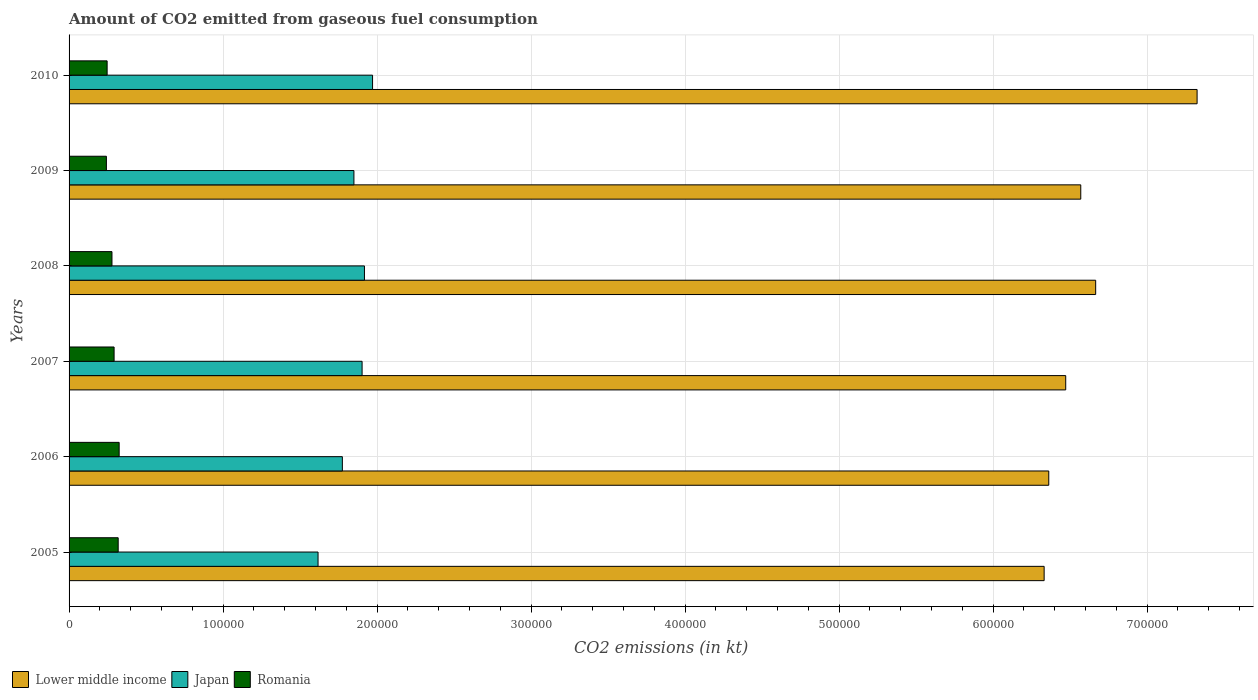How many groups of bars are there?
Ensure brevity in your answer.  6. Are the number of bars per tick equal to the number of legend labels?
Your response must be concise. Yes. In how many cases, is the number of bars for a given year not equal to the number of legend labels?
Keep it short and to the point. 0. What is the amount of CO2 emitted in Romania in 2006?
Provide a succinct answer. 3.25e+04. Across all years, what is the maximum amount of CO2 emitted in Romania?
Your response must be concise. 3.25e+04. Across all years, what is the minimum amount of CO2 emitted in Japan?
Give a very brief answer. 1.62e+05. In which year was the amount of CO2 emitted in Lower middle income minimum?
Offer a terse response. 2005. What is the total amount of CO2 emitted in Romania in the graph?
Provide a succinct answer. 1.70e+05. What is the difference between the amount of CO2 emitted in Romania in 2007 and that in 2009?
Ensure brevity in your answer.  4998.12. What is the difference between the amount of CO2 emitted in Romania in 2009 and the amount of CO2 emitted in Japan in 2007?
Your answer should be compact. -1.66e+05. What is the average amount of CO2 emitted in Japan per year?
Make the answer very short. 1.84e+05. In the year 2006, what is the difference between the amount of CO2 emitted in Japan and amount of CO2 emitted in Lower middle income?
Give a very brief answer. -4.59e+05. In how many years, is the amount of CO2 emitted in Japan greater than 200000 kt?
Keep it short and to the point. 0. What is the ratio of the amount of CO2 emitted in Japan in 2007 to that in 2009?
Make the answer very short. 1.03. Is the difference between the amount of CO2 emitted in Japan in 2009 and 2010 greater than the difference between the amount of CO2 emitted in Lower middle income in 2009 and 2010?
Make the answer very short. Yes. What is the difference between the highest and the second highest amount of CO2 emitted in Lower middle income?
Provide a short and direct response. 6.59e+04. What is the difference between the highest and the lowest amount of CO2 emitted in Lower middle income?
Keep it short and to the point. 9.93e+04. In how many years, is the amount of CO2 emitted in Japan greater than the average amount of CO2 emitted in Japan taken over all years?
Keep it short and to the point. 4. Is the sum of the amount of CO2 emitted in Lower middle income in 2006 and 2010 greater than the maximum amount of CO2 emitted in Japan across all years?
Make the answer very short. Yes. What does the 3rd bar from the top in 2006 represents?
Provide a short and direct response. Lower middle income. What does the 3rd bar from the bottom in 2009 represents?
Your answer should be compact. Romania. How many bars are there?
Offer a very short reply. 18. How many legend labels are there?
Give a very brief answer. 3. How are the legend labels stacked?
Offer a very short reply. Horizontal. What is the title of the graph?
Offer a very short reply. Amount of CO2 emitted from gaseous fuel consumption. Does "Qatar" appear as one of the legend labels in the graph?
Give a very brief answer. No. What is the label or title of the X-axis?
Ensure brevity in your answer.  CO2 emissions (in kt). What is the CO2 emissions (in kt) in Lower middle income in 2005?
Your answer should be compact. 6.33e+05. What is the CO2 emissions (in kt) of Japan in 2005?
Give a very brief answer. 1.62e+05. What is the CO2 emissions (in kt) in Romania in 2005?
Your answer should be very brief. 3.19e+04. What is the CO2 emissions (in kt) of Lower middle income in 2006?
Ensure brevity in your answer.  6.36e+05. What is the CO2 emissions (in kt) in Japan in 2006?
Offer a very short reply. 1.77e+05. What is the CO2 emissions (in kt) in Romania in 2006?
Give a very brief answer. 3.25e+04. What is the CO2 emissions (in kt) of Lower middle income in 2007?
Offer a terse response. 6.47e+05. What is the CO2 emissions (in kt) in Japan in 2007?
Offer a terse response. 1.90e+05. What is the CO2 emissions (in kt) of Romania in 2007?
Your answer should be very brief. 2.92e+04. What is the CO2 emissions (in kt) in Lower middle income in 2008?
Offer a terse response. 6.67e+05. What is the CO2 emissions (in kt) in Japan in 2008?
Ensure brevity in your answer.  1.92e+05. What is the CO2 emissions (in kt) in Romania in 2008?
Your answer should be compact. 2.79e+04. What is the CO2 emissions (in kt) of Lower middle income in 2009?
Ensure brevity in your answer.  6.57e+05. What is the CO2 emissions (in kt) of Japan in 2009?
Provide a succinct answer. 1.85e+05. What is the CO2 emissions (in kt) in Romania in 2009?
Keep it short and to the point. 2.42e+04. What is the CO2 emissions (in kt) in Lower middle income in 2010?
Your answer should be very brief. 7.32e+05. What is the CO2 emissions (in kt) in Japan in 2010?
Offer a very short reply. 1.97e+05. What is the CO2 emissions (in kt) in Romania in 2010?
Provide a succinct answer. 2.47e+04. Across all years, what is the maximum CO2 emissions (in kt) of Lower middle income?
Offer a terse response. 7.32e+05. Across all years, what is the maximum CO2 emissions (in kt) in Japan?
Offer a very short reply. 1.97e+05. Across all years, what is the maximum CO2 emissions (in kt) of Romania?
Make the answer very short. 3.25e+04. Across all years, what is the minimum CO2 emissions (in kt) of Lower middle income?
Offer a very short reply. 6.33e+05. Across all years, what is the minimum CO2 emissions (in kt) in Japan?
Your answer should be compact. 1.62e+05. Across all years, what is the minimum CO2 emissions (in kt) of Romania?
Keep it short and to the point. 2.42e+04. What is the total CO2 emissions (in kt) in Lower middle income in the graph?
Your answer should be compact. 3.97e+06. What is the total CO2 emissions (in kt) of Japan in the graph?
Keep it short and to the point. 1.10e+06. What is the total CO2 emissions (in kt) of Romania in the graph?
Your response must be concise. 1.70e+05. What is the difference between the CO2 emissions (in kt) in Lower middle income in 2005 and that in 2006?
Your answer should be compact. -3003.93. What is the difference between the CO2 emissions (in kt) of Japan in 2005 and that in 2006?
Keep it short and to the point. -1.58e+04. What is the difference between the CO2 emissions (in kt) of Romania in 2005 and that in 2006?
Make the answer very short. -630.72. What is the difference between the CO2 emissions (in kt) of Lower middle income in 2005 and that in 2007?
Provide a short and direct response. -1.40e+04. What is the difference between the CO2 emissions (in kt) of Japan in 2005 and that in 2007?
Ensure brevity in your answer.  -2.86e+04. What is the difference between the CO2 emissions (in kt) in Romania in 2005 and that in 2007?
Make the answer very short. 2658.57. What is the difference between the CO2 emissions (in kt) of Lower middle income in 2005 and that in 2008?
Your answer should be very brief. -3.35e+04. What is the difference between the CO2 emissions (in kt) of Japan in 2005 and that in 2008?
Provide a short and direct response. -3.01e+04. What is the difference between the CO2 emissions (in kt) in Romania in 2005 and that in 2008?
Provide a short and direct response. 4037.37. What is the difference between the CO2 emissions (in kt) in Lower middle income in 2005 and that in 2009?
Provide a short and direct response. -2.38e+04. What is the difference between the CO2 emissions (in kt) in Japan in 2005 and that in 2009?
Your response must be concise. -2.33e+04. What is the difference between the CO2 emissions (in kt) in Romania in 2005 and that in 2009?
Make the answer very short. 7656.7. What is the difference between the CO2 emissions (in kt) of Lower middle income in 2005 and that in 2010?
Offer a terse response. -9.93e+04. What is the difference between the CO2 emissions (in kt) in Japan in 2005 and that in 2010?
Provide a short and direct response. -3.54e+04. What is the difference between the CO2 emissions (in kt) of Romania in 2005 and that in 2010?
Make the answer very short. 7179.99. What is the difference between the CO2 emissions (in kt) in Lower middle income in 2006 and that in 2007?
Ensure brevity in your answer.  -1.10e+04. What is the difference between the CO2 emissions (in kt) in Japan in 2006 and that in 2007?
Your answer should be compact. -1.28e+04. What is the difference between the CO2 emissions (in kt) in Romania in 2006 and that in 2007?
Ensure brevity in your answer.  3289.3. What is the difference between the CO2 emissions (in kt) of Lower middle income in 2006 and that in 2008?
Offer a terse response. -3.04e+04. What is the difference between the CO2 emissions (in kt) in Japan in 2006 and that in 2008?
Your response must be concise. -1.43e+04. What is the difference between the CO2 emissions (in kt) of Romania in 2006 and that in 2008?
Offer a terse response. 4668.09. What is the difference between the CO2 emissions (in kt) of Lower middle income in 2006 and that in 2009?
Offer a very short reply. -2.08e+04. What is the difference between the CO2 emissions (in kt) of Japan in 2006 and that in 2009?
Offer a very short reply. -7510.02. What is the difference between the CO2 emissions (in kt) of Romania in 2006 and that in 2009?
Your answer should be very brief. 8287.42. What is the difference between the CO2 emissions (in kt) of Lower middle income in 2006 and that in 2010?
Your answer should be compact. -9.63e+04. What is the difference between the CO2 emissions (in kt) in Japan in 2006 and that in 2010?
Offer a very short reply. -1.96e+04. What is the difference between the CO2 emissions (in kt) of Romania in 2006 and that in 2010?
Ensure brevity in your answer.  7810.71. What is the difference between the CO2 emissions (in kt) in Lower middle income in 2007 and that in 2008?
Provide a short and direct response. -1.94e+04. What is the difference between the CO2 emissions (in kt) in Japan in 2007 and that in 2008?
Your response must be concise. -1532.81. What is the difference between the CO2 emissions (in kt) in Romania in 2007 and that in 2008?
Make the answer very short. 1378.79. What is the difference between the CO2 emissions (in kt) in Lower middle income in 2007 and that in 2009?
Make the answer very short. -9769.55. What is the difference between the CO2 emissions (in kt) in Japan in 2007 and that in 2009?
Keep it short and to the point. 5298.81. What is the difference between the CO2 emissions (in kt) in Romania in 2007 and that in 2009?
Your answer should be very brief. 4998.12. What is the difference between the CO2 emissions (in kt) in Lower middle income in 2007 and that in 2010?
Your answer should be compact. -8.53e+04. What is the difference between the CO2 emissions (in kt) of Japan in 2007 and that in 2010?
Your response must be concise. -6802.28. What is the difference between the CO2 emissions (in kt) of Romania in 2007 and that in 2010?
Provide a short and direct response. 4521.41. What is the difference between the CO2 emissions (in kt) in Lower middle income in 2008 and that in 2009?
Offer a terse response. 9672.51. What is the difference between the CO2 emissions (in kt) in Japan in 2008 and that in 2009?
Your answer should be compact. 6831.62. What is the difference between the CO2 emissions (in kt) in Romania in 2008 and that in 2009?
Offer a terse response. 3619.33. What is the difference between the CO2 emissions (in kt) of Lower middle income in 2008 and that in 2010?
Offer a terse response. -6.59e+04. What is the difference between the CO2 emissions (in kt) of Japan in 2008 and that in 2010?
Provide a succinct answer. -5269.48. What is the difference between the CO2 emissions (in kt) of Romania in 2008 and that in 2010?
Provide a succinct answer. 3142.62. What is the difference between the CO2 emissions (in kt) of Lower middle income in 2009 and that in 2010?
Ensure brevity in your answer.  -7.55e+04. What is the difference between the CO2 emissions (in kt) of Japan in 2009 and that in 2010?
Offer a terse response. -1.21e+04. What is the difference between the CO2 emissions (in kt) of Romania in 2009 and that in 2010?
Keep it short and to the point. -476.71. What is the difference between the CO2 emissions (in kt) of Lower middle income in 2005 and the CO2 emissions (in kt) of Japan in 2006?
Your answer should be very brief. 4.56e+05. What is the difference between the CO2 emissions (in kt) of Lower middle income in 2005 and the CO2 emissions (in kt) of Romania in 2006?
Keep it short and to the point. 6.01e+05. What is the difference between the CO2 emissions (in kt) in Japan in 2005 and the CO2 emissions (in kt) in Romania in 2006?
Your answer should be compact. 1.29e+05. What is the difference between the CO2 emissions (in kt) of Lower middle income in 2005 and the CO2 emissions (in kt) of Japan in 2007?
Keep it short and to the point. 4.43e+05. What is the difference between the CO2 emissions (in kt) in Lower middle income in 2005 and the CO2 emissions (in kt) in Romania in 2007?
Ensure brevity in your answer.  6.04e+05. What is the difference between the CO2 emissions (in kt) of Japan in 2005 and the CO2 emissions (in kt) of Romania in 2007?
Your answer should be very brief. 1.32e+05. What is the difference between the CO2 emissions (in kt) in Lower middle income in 2005 and the CO2 emissions (in kt) in Japan in 2008?
Make the answer very short. 4.41e+05. What is the difference between the CO2 emissions (in kt) in Lower middle income in 2005 and the CO2 emissions (in kt) in Romania in 2008?
Give a very brief answer. 6.05e+05. What is the difference between the CO2 emissions (in kt) of Japan in 2005 and the CO2 emissions (in kt) of Romania in 2008?
Your answer should be compact. 1.34e+05. What is the difference between the CO2 emissions (in kt) of Lower middle income in 2005 and the CO2 emissions (in kt) of Japan in 2009?
Your answer should be very brief. 4.48e+05. What is the difference between the CO2 emissions (in kt) of Lower middle income in 2005 and the CO2 emissions (in kt) of Romania in 2009?
Your response must be concise. 6.09e+05. What is the difference between the CO2 emissions (in kt) in Japan in 2005 and the CO2 emissions (in kt) in Romania in 2009?
Your answer should be very brief. 1.37e+05. What is the difference between the CO2 emissions (in kt) in Lower middle income in 2005 and the CO2 emissions (in kt) in Japan in 2010?
Provide a succinct answer. 4.36e+05. What is the difference between the CO2 emissions (in kt) in Lower middle income in 2005 and the CO2 emissions (in kt) in Romania in 2010?
Your answer should be very brief. 6.08e+05. What is the difference between the CO2 emissions (in kt) in Japan in 2005 and the CO2 emissions (in kt) in Romania in 2010?
Ensure brevity in your answer.  1.37e+05. What is the difference between the CO2 emissions (in kt) of Lower middle income in 2006 and the CO2 emissions (in kt) of Japan in 2007?
Your answer should be compact. 4.46e+05. What is the difference between the CO2 emissions (in kt) of Lower middle income in 2006 and the CO2 emissions (in kt) of Romania in 2007?
Make the answer very short. 6.07e+05. What is the difference between the CO2 emissions (in kt) of Japan in 2006 and the CO2 emissions (in kt) of Romania in 2007?
Your answer should be compact. 1.48e+05. What is the difference between the CO2 emissions (in kt) in Lower middle income in 2006 and the CO2 emissions (in kt) in Japan in 2008?
Make the answer very short. 4.44e+05. What is the difference between the CO2 emissions (in kt) of Lower middle income in 2006 and the CO2 emissions (in kt) of Romania in 2008?
Your response must be concise. 6.08e+05. What is the difference between the CO2 emissions (in kt) of Japan in 2006 and the CO2 emissions (in kt) of Romania in 2008?
Offer a very short reply. 1.50e+05. What is the difference between the CO2 emissions (in kt) of Lower middle income in 2006 and the CO2 emissions (in kt) of Japan in 2009?
Make the answer very short. 4.51e+05. What is the difference between the CO2 emissions (in kt) of Lower middle income in 2006 and the CO2 emissions (in kt) of Romania in 2009?
Make the answer very short. 6.12e+05. What is the difference between the CO2 emissions (in kt) of Japan in 2006 and the CO2 emissions (in kt) of Romania in 2009?
Offer a very short reply. 1.53e+05. What is the difference between the CO2 emissions (in kt) in Lower middle income in 2006 and the CO2 emissions (in kt) in Japan in 2010?
Your answer should be compact. 4.39e+05. What is the difference between the CO2 emissions (in kt) of Lower middle income in 2006 and the CO2 emissions (in kt) of Romania in 2010?
Your answer should be compact. 6.11e+05. What is the difference between the CO2 emissions (in kt) in Japan in 2006 and the CO2 emissions (in kt) in Romania in 2010?
Your response must be concise. 1.53e+05. What is the difference between the CO2 emissions (in kt) of Lower middle income in 2007 and the CO2 emissions (in kt) of Japan in 2008?
Your answer should be compact. 4.55e+05. What is the difference between the CO2 emissions (in kt) in Lower middle income in 2007 and the CO2 emissions (in kt) in Romania in 2008?
Provide a short and direct response. 6.19e+05. What is the difference between the CO2 emissions (in kt) in Japan in 2007 and the CO2 emissions (in kt) in Romania in 2008?
Make the answer very short. 1.62e+05. What is the difference between the CO2 emissions (in kt) of Lower middle income in 2007 and the CO2 emissions (in kt) of Japan in 2009?
Your answer should be compact. 4.62e+05. What is the difference between the CO2 emissions (in kt) of Lower middle income in 2007 and the CO2 emissions (in kt) of Romania in 2009?
Your answer should be compact. 6.23e+05. What is the difference between the CO2 emissions (in kt) of Japan in 2007 and the CO2 emissions (in kt) of Romania in 2009?
Give a very brief answer. 1.66e+05. What is the difference between the CO2 emissions (in kt) of Lower middle income in 2007 and the CO2 emissions (in kt) of Japan in 2010?
Ensure brevity in your answer.  4.50e+05. What is the difference between the CO2 emissions (in kt) in Lower middle income in 2007 and the CO2 emissions (in kt) in Romania in 2010?
Offer a terse response. 6.22e+05. What is the difference between the CO2 emissions (in kt) in Japan in 2007 and the CO2 emissions (in kt) in Romania in 2010?
Your response must be concise. 1.66e+05. What is the difference between the CO2 emissions (in kt) of Lower middle income in 2008 and the CO2 emissions (in kt) of Japan in 2009?
Make the answer very short. 4.82e+05. What is the difference between the CO2 emissions (in kt) in Lower middle income in 2008 and the CO2 emissions (in kt) in Romania in 2009?
Ensure brevity in your answer.  6.42e+05. What is the difference between the CO2 emissions (in kt) of Japan in 2008 and the CO2 emissions (in kt) of Romania in 2009?
Ensure brevity in your answer.  1.68e+05. What is the difference between the CO2 emissions (in kt) in Lower middle income in 2008 and the CO2 emissions (in kt) in Japan in 2010?
Ensure brevity in your answer.  4.70e+05. What is the difference between the CO2 emissions (in kt) of Lower middle income in 2008 and the CO2 emissions (in kt) of Romania in 2010?
Offer a very short reply. 6.42e+05. What is the difference between the CO2 emissions (in kt) of Japan in 2008 and the CO2 emissions (in kt) of Romania in 2010?
Provide a succinct answer. 1.67e+05. What is the difference between the CO2 emissions (in kt) in Lower middle income in 2009 and the CO2 emissions (in kt) in Japan in 2010?
Your answer should be compact. 4.60e+05. What is the difference between the CO2 emissions (in kt) in Lower middle income in 2009 and the CO2 emissions (in kt) in Romania in 2010?
Your answer should be compact. 6.32e+05. What is the difference between the CO2 emissions (in kt) of Japan in 2009 and the CO2 emissions (in kt) of Romania in 2010?
Your response must be concise. 1.60e+05. What is the average CO2 emissions (in kt) in Lower middle income per year?
Ensure brevity in your answer.  6.62e+05. What is the average CO2 emissions (in kt) in Japan per year?
Your response must be concise. 1.84e+05. What is the average CO2 emissions (in kt) of Romania per year?
Provide a short and direct response. 2.84e+04. In the year 2005, what is the difference between the CO2 emissions (in kt) of Lower middle income and CO2 emissions (in kt) of Japan?
Offer a terse response. 4.71e+05. In the year 2005, what is the difference between the CO2 emissions (in kt) of Lower middle income and CO2 emissions (in kt) of Romania?
Provide a short and direct response. 6.01e+05. In the year 2005, what is the difference between the CO2 emissions (in kt) of Japan and CO2 emissions (in kt) of Romania?
Keep it short and to the point. 1.30e+05. In the year 2006, what is the difference between the CO2 emissions (in kt) in Lower middle income and CO2 emissions (in kt) in Japan?
Make the answer very short. 4.59e+05. In the year 2006, what is the difference between the CO2 emissions (in kt) in Lower middle income and CO2 emissions (in kt) in Romania?
Offer a very short reply. 6.04e+05. In the year 2006, what is the difference between the CO2 emissions (in kt) in Japan and CO2 emissions (in kt) in Romania?
Make the answer very short. 1.45e+05. In the year 2007, what is the difference between the CO2 emissions (in kt) of Lower middle income and CO2 emissions (in kt) of Japan?
Your answer should be very brief. 4.57e+05. In the year 2007, what is the difference between the CO2 emissions (in kt) of Lower middle income and CO2 emissions (in kt) of Romania?
Provide a succinct answer. 6.18e+05. In the year 2007, what is the difference between the CO2 emissions (in kt) in Japan and CO2 emissions (in kt) in Romania?
Provide a short and direct response. 1.61e+05. In the year 2008, what is the difference between the CO2 emissions (in kt) of Lower middle income and CO2 emissions (in kt) of Japan?
Keep it short and to the point. 4.75e+05. In the year 2008, what is the difference between the CO2 emissions (in kt) in Lower middle income and CO2 emissions (in kt) in Romania?
Provide a succinct answer. 6.39e+05. In the year 2008, what is the difference between the CO2 emissions (in kt) in Japan and CO2 emissions (in kt) in Romania?
Provide a short and direct response. 1.64e+05. In the year 2009, what is the difference between the CO2 emissions (in kt) in Lower middle income and CO2 emissions (in kt) in Japan?
Provide a short and direct response. 4.72e+05. In the year 2009, what is the difference between the CO2 emissions (in kt) of Lower middle income and CO2 emissions (in kt) of Romania?
Offer a terse response. 6.33e+05. In the year 2009, what is the difference between the CO2 emissions (in kt) in Japan and CO2 emissions (in kt) in Romania?
Your answer should be compact. 1.61e+05. In the year 2010, what is the difference between the CO2 emissions (in kt) in Lower middle income and CO2 emissions (in kt) in Japan?
Your response must be concise. 5.35e+05. In the year 2010, what is the difference between the CO2 emissions (in kt) in Lower middle income and CO2 emissions (in kt) in Romania?
Ensure brevity in your answer.  7.08e+05. In the year 2010, what is the difference between the CO2 emissions (in kt) of Japan and CO2 emissions (in kt) of Romania?
Your answer should be compact. 1.72e+05. What is the ratio of the CO2 emissions (in kt) of Japan in 2005 to that in 2006?
Offer a very short reply. 0.91. What is the ratio of the CO2 emissions (in kt) in Romania in 2005 to that in 2006?
Make the answer very short. 0.98. What is the ratio of the CO2 emissions (in kt) of Lower middle income in 2005 to that in 2007?
Your answer should be compact. 0.98. What is the ratio of the CO2 emissions (in kt) in Japan in 2005 to that in 2007?
Your answer should be compact. 0.85. What is the ratio of the CO2 emissions (in kt) of Romania in 2005 to that in 2007?
Make the answer very short. 1.09. What is the ratio of the CO2 emissions (in kt) in Lower middle income in 2005 to that in 2008?
Give a very brief answer. 0.95. What is the ratio of the CO2 emissions (in kt) in Japan in 2005 to that in 2008?
Ensure brevity in your answer.  0.84. What is the ratio of the CO2 emissions (in kt) in Romania in 2005 to that in 2008?
Keep it short and to the point. 1.15. What is the ratio of the CO2 emissions (in kt) of Lower middle income in 2005 to that in 2009?
Make the answer very short. 0.96. What is the ratio of the CO2 emissions (in kt) of Japan in 2005 to that in 2009?
Offer a very short reply. 0.87. What is the ratio of the CO2 emissions (in kt) in Romania in 2005 to that in 2009?
Your answer should be compact. 1.32. What is the ratio of the CO2 emissions (in kt) in Lower middle income in 2005 to that in 2010?
Provide a succinct answer. 0.86. What is the ratio of the CO2 emissions (in kt) of Japan in 2005 to that in 2010?
Your answer should be compact. 0.82. What is the ratio of the CO2 emissions (in kt) in Romania in 2005 to that in 2010?
Keep it short and to the point. 1.29. What is the ratio of the CO2 emissions (in kt) in Lower middle income in 2006 to that in 2007?
Give a very brief answer. 0.98. What is the ratio of the CO2 emissions (in kt) in Japan in 2006 to that in 2007?
Give a very brief answer. 0.93. What is the ratio of the CO2 emissions (in kt) in Romania in 2006 to that in 2007?
Keep it short and to the point. 1.11. What is the ratio of the CO2 emissions (in kt) of Lower middle income in 2006 to that in 2008?
Ensure brevity in your answer.  0.95. What is the ratio of the CO2 emissions (in kt) in Japan in 2006 to that in 2008?
Offer a terse response. 0.93. What is the ratio of the CO2 emissions (in kt) in Romania in 2006 to that in 2008?
Provide a short and direct response. 1.17. What is the ratio of the CO2 emissions (in kt) in Lower middle income in 2006 to that in 2009?
Offer a terse response. 0.97. What is the ratio of the CO2 emissions (in kt) in Japan in 2006 to that in 2009?
Give a very brief answer. 0.96. What is the ratio of the CO2 emissions (in kt) of Romania in 2006 to that in 2009?
Your answer should be very brief. 1.34. What is the ratio of the CO2 emissions (in kt) in Lower middle income in 2006 to that in 2010?
Keep it short and to the point. 0.87. What is the ratio of the CO2 emissions (in kt) of Japan in 2006 to that in 2010?
Your answer should be very brief. 0.9. What is the ratio of the CO2 emissions (in kt) in Romania in 2006 to that in 2010?
Offer a terse response. 1.32. What is the ratio of the CO2 emissions (in kt) in Lower middle income in 2007 to that in 2008?
Give a very brief answer. 0.97. What is the ratio of the CO2 emissions (in kt) in Japan in 2007 to that in 2008?
Provide a short and direct response. 0.99. What is the ratio of the CO2 emissions (in kt) in Romania in 2007 to that in 2008?
Offer a terse response. 1.05. What is the ratio of the CO2 emissions (in kt) of Lower middle income in 2007 to that in 2009?
Your response must be concise. 0.99. What is the ratio of the CO2 emissions (in kt) of Japan in 2007 to that in 2009?
Provide a short and direct response. 1.03. What is the ratio of the CO2 emissions (in kt) of Romania in 2007 to that in 2009?
Your answer should be compact. 1.21. What is the ratio of the CO2 emissions (in kt) in Lower middle income in 2007 to that in 2010?
Offer a very short reply. 0.88. What is the ratio of the CO2 emissions (in kt) in Japan in 2007 to that in 2010?
Make the answer very short. 0.97. What is the ratio of the CO2 emissions (in kt) of Romania in 2007 to that in 2010?
Give a very brief answer. 1.18. What is the ratio of the CO2 emissions (in kt) of Lower middle income in 2008 to that in 2009?
Provide a succinct answer. 1.01. What is the ratio of the CO2 emissions (in kt) in Japan in 2008 to that in 2009?
Your response must be concise. 1.04. What is the ratio of the CO2 emissions (in kt) of Romania in 2008 to that in 2009?
Make the answer very short. 1.15. What is the ratio of the CO2 emissions (in kt) of Lower middle income in 2008 to that in 2010?
Your answer should be very brief. 0.91. What is the ratio of the CO2 emissions (in kt) of Japan in 2008 to that in 2010?
Provide a succinct answer. 0.97. What is the ratio of the CO2 emissions (in kt) of Romania in 2008 to that in 2010?
Offer a very short reply. 1.13. What is the ratio of the CO2 emissions (in kt) in Lower middle income in 2009 to that in 2010?
Offer a terse response. 0.9. What is the ratio of the CO2 emissions (in kt) in Japan in 2009 to that in 2010?
Your answer should be very brief. 0.94. What is the ratio of the CO2 emissions (in kt) in Romania in 2009 to that in 2010?
Provide a short and direct response. 0.98. What is the difference between the highest and the second highest CO2 emissions (in kt) in Lower middle income?
Keep it short and to the point. 6.59e+04. What is the difference between the highest and the second highest CO2 emissions (in kt) of Japan?
Provide a short and direct response. 5269.48. What is the difference between the highest and the second highest CO2 emissions (in kt) in Romania?
Ensure brevity in your answer.  630.72. What is the difference between the highest and the lowest CO2 emissions (in kt) of Lower middle income?
Ensure brevity in your answer.  9.93e+04. What is the difference between the highest and the lowest CO2 emissions (in kt) of Japan?
Your response must be concise. 3.54e+04. What is the difference between the highest and the lowest CO2 emissions (in kt) in Romania?
Your answer should be very brief. 8287.42. 